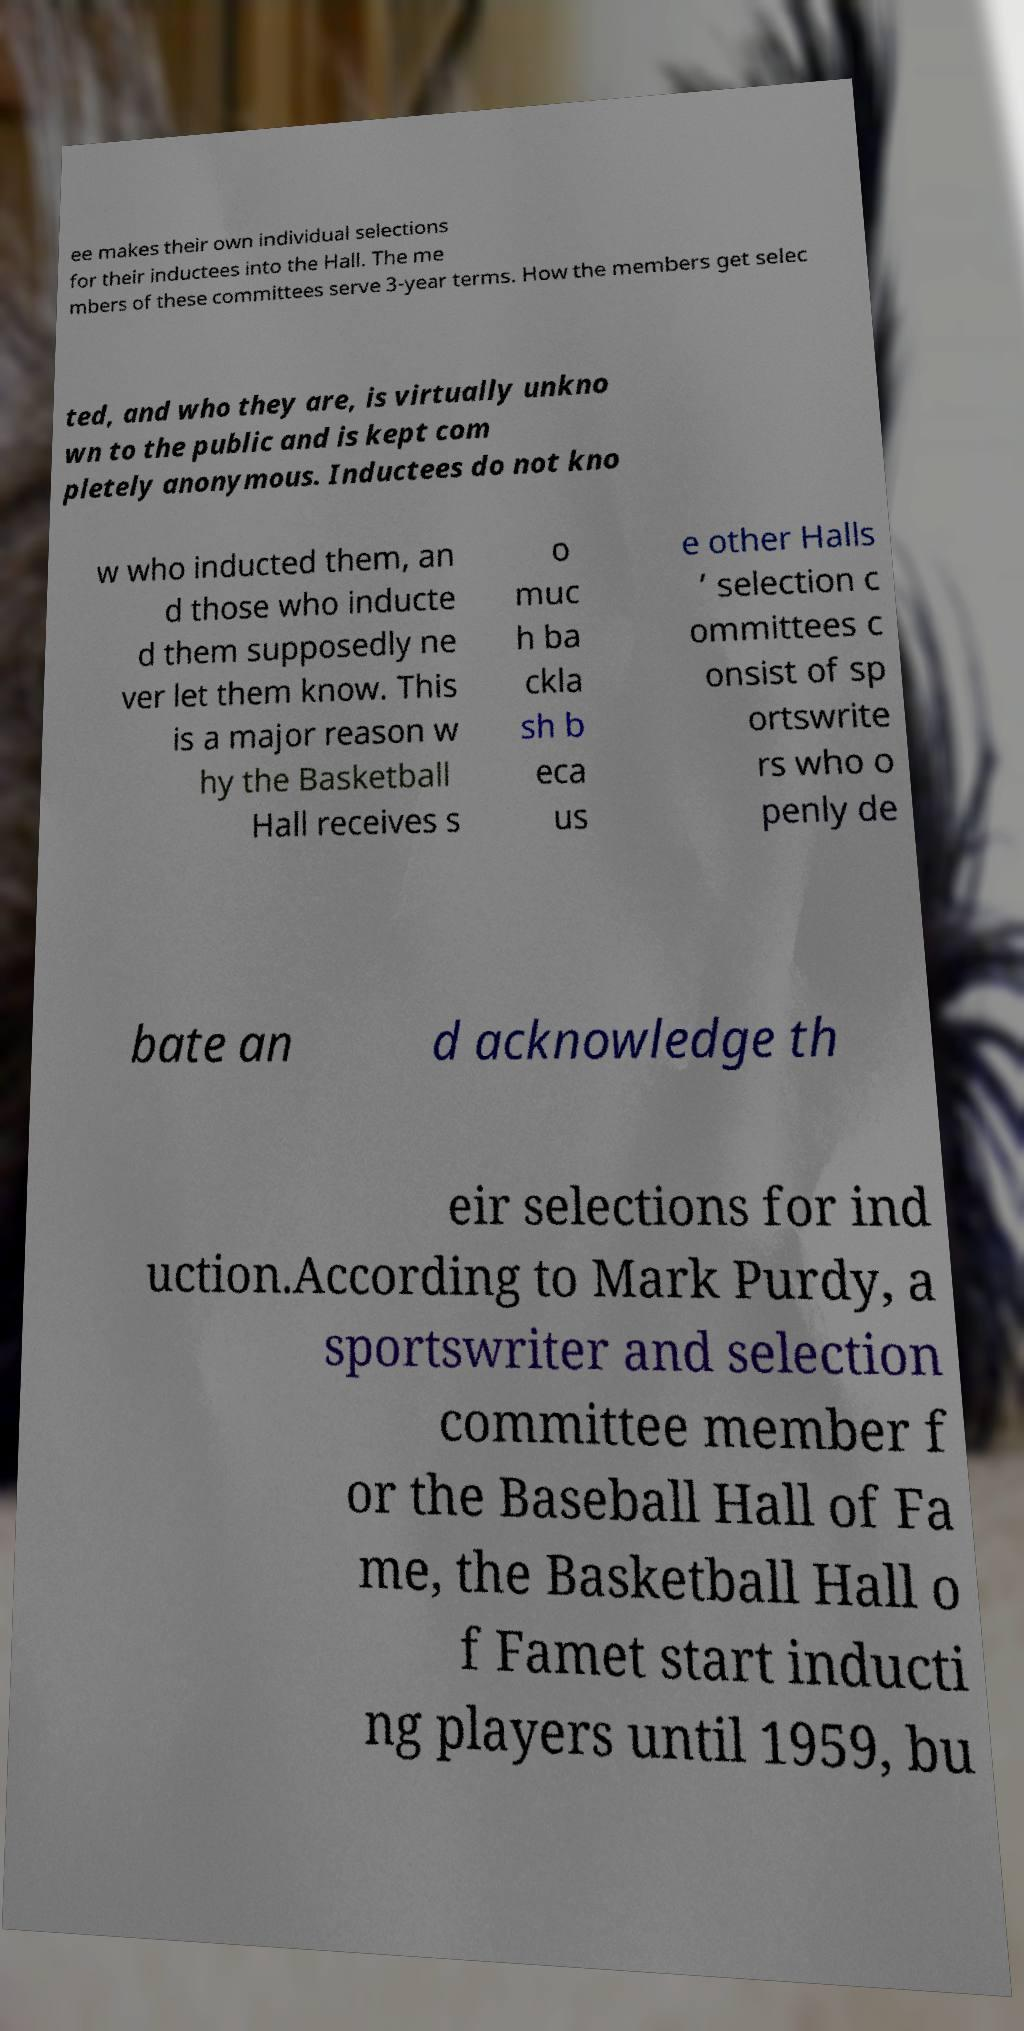I need the written content from this picture converted into text. Can you do that? ee makes their own individual selections for their inductees into the Hall. The me mbers of these committees serve 3-year terms. How the members get selec ted, and who they are, is virtually unkno wn to the public and is kept com pletely anonymous. Inductees do not kno w who inducted them, an d those who inducte d them supposedly ne ver let them know. This is a major reason w hy the Basketball Hall receives s o muc h ba ckla sh b eca us e other Halls ’ selection c ommittees c onsist of sp ortswrite rs who o penly de bate an d acknowledge th eir selections for ind uction.According to Mark Purdy, a sportswriter and selection committee member f or the Baseball Hall of Fa me, the Basketball Hall o f Famet start inducti ng players until 1959, bu 